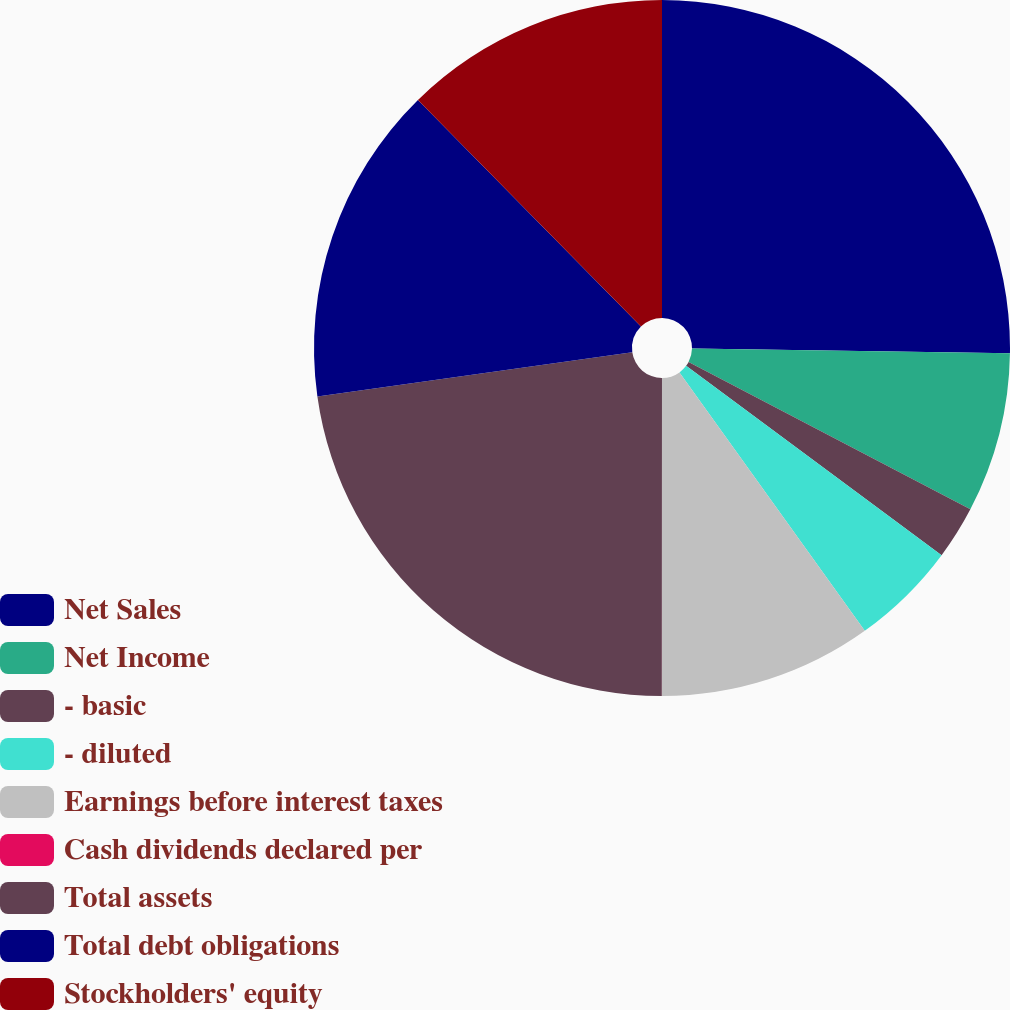Convert chart. <chart><loc_0><loc_0><loc_500><loc_500><pie_chart><fcel>Net Sales<fcel>Net Income<fcel>- basic<fcel>- diluted<fcel>Earnings before interest taxes<fcel>Cash dividends declared per<fcel>Total assets<fcel>Total debt obligations<fcel>Stockholders' equity<nl><fcel>25.24%<fcel>7.43%<fcel>2.48%<fcel>4.95%<fcel>9.9%<fcel>0.01%<fcel>22.77%<fcel>14.85%<fcel>12.37%<nl></chart> 